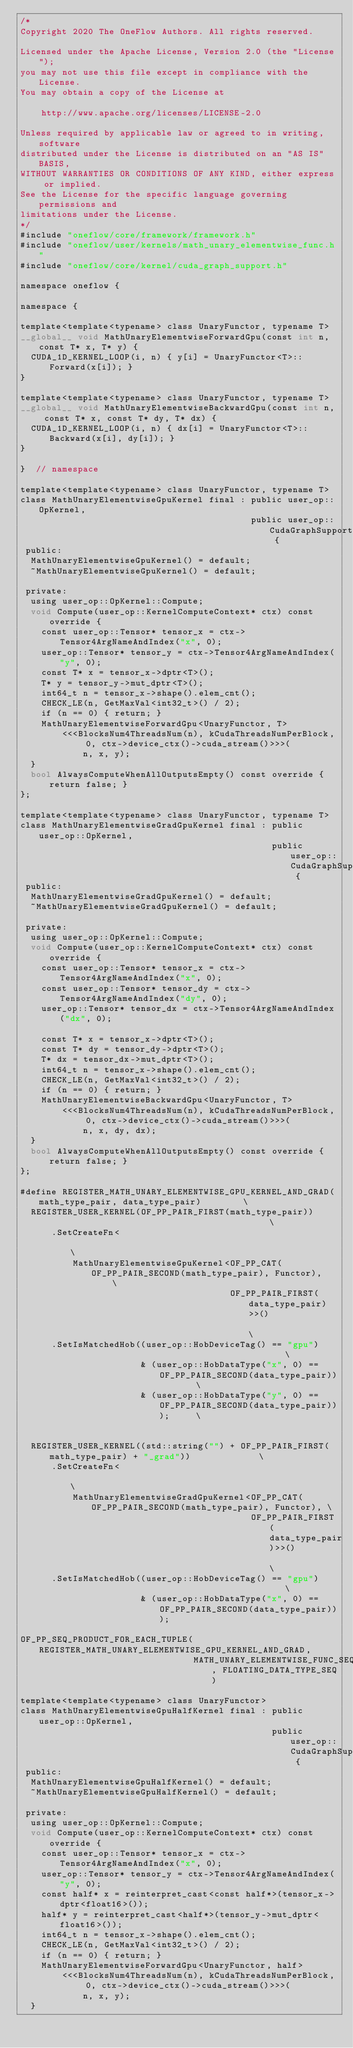Convert code to text. <code><loc_0><loc_0><loc_500><loc_500><_Cuda_>/*
Copyright 2020 The OneFlow Authors. All rights reserved.

Licensed under the Apache License, Version 2.0 (the "License");
you may not use this file except in compliance with the License.
You may obtain a copy of the License at

    http://www.apache.org/licenses/LICENSE-2.0

Unless required by applicable law or agreed to in writing, software
distributed under the License is distributed on an "AS IS" BASIS,
WITHOUT WARRANTIES OR CONDITIONS OF ANY KIND, either express or implied.
See the License for the specific language governing permissions and
limitations under the License.
*/
#include "oneflow/core/framework/framework.h"
#include "oneflow/user/kernels/math_unary_elementwise_func.h"
#include "oneflow/core/kernel/cuda_graph_support.h"

namespace oneflow {

namespace {

template<template<typename> class UnaryFunctor, typename T>
__global__ void MathUnaryElementwiseForwardGpu(const int n, const T* x, T* y) {
  CUDA_1D_KERNEL_LOOP(i, n) { y[i] = UnaryFunctor<T>::Forward(x[i]); }
}

template<template<typename> class UnaryFunctor, typename T>
__global__ void MathUnaryElementwiseBackwardGpu(const int n, const T* x, const T* dy, T* dx) {
  CUDA_1D_KERNEL_LOOP(i, n) { dx[i] = UnaryFunctor<T>::Backward(x[i], dy[i]); }
}

}  // namespace

template<template<typename> class UnaryFunctor, typename T>
class MathUnaryElementwiseGpuKernel final : public user_op::OpKernel,
                                            public user_op::CudaGraphSupport {
 public:
  MathUnaryElementwiseGpuKernel() = default;
  ~MathUnaryElementwiseGpuKernel() = default;

 private:
  using user_op::OpKernel::Compute;
  void Compute(user_op::KernelComputeContext* ctx) const override {
    const user_op::Tensor* tensor_x = ctx->Tensor4ArgNameAndIndex("x", 0);
    user_op::Tensor* tensor_y = ctx->Tensor4ArgNameAndIndex("y", 0);
    const T* x = tensor_x->dptr<T>();
    T* y = tensor_y->mut_dptr<T>();
    int64_t n = tensor_x->shape().elem_cnt();
    CHECK_LE(n, GetMaxVal<int32_t>() / 2);
    if (n == 0) { return; }
    MathUnaryElementwiseForwardGpu<UnaryFunctor, T>
        <<<BlocksNum4ThreadsNum(n), kCudaThreadsNumPerBlock, 0, ctx->device_ctx()->cuda_stream()>>>(
            n, x, y);
  }
  bool AlwaysComputeWhenAllOutputsEmpty() const override { return false; }
};

template<template<typename> class UnaryFunctor, typename T>
class MathUnaryElementwiseGradGpuKernel final : public user_op::OpKernel,
                                                public user_op::CudaGraphSupport {
 public:
  MathUnaryElementwiseGradGpuKernel() = default;
  ~MathUnaryElementwiseGradGpuKernel() = default;

 private:
  using user_op::OpKernel::Compute;
  void Compute(user_op::KernelComputeContext* ctx) const override {
    const user_op::Tensor* tensor_x = ctx->Tensor4ArgNameAndIndex("x", 0);
    const user_op::Tensor* tensor_dy = ctx->Tensor4ArgNameAndIndex("dy", 0);
    user_op::Tensor* tensor_dx = ctx->Tensor4ArgNameAndIndex("dx", 0);

    const T* x = tensor_x->dptr<T>();
    const T* dy = tensor_dy->dptr<T>();
    T* dx = tensor_dx->mut_dptr<T>();
    int64_t n = tensor_x->shape().elem_cnt();
    CHECK_LE(n, GetMaxVal<int32_t>() / 2);
    if (n == 0) { return; }
    MathUnaryElementwiseBackwardGpu<UnaryFunctor, T>
        <<<BlocksNum4ThreadsNum(n), kCudaThreadsNumPerBlock, 0, ctx->device_ctx()->cuda_stream()>>>(
            n, x, dy, dx);
  }
  bool AlwaysComputeWhenAllOutputsEmpty() const override { return false; }
};

#define REGISTER_MATH_UNARY_ELEMENTWISE_GPU_KERNEL_AND_GRAD(math_type_pair, data_type_pair)        \
  REGISTER_USER_KERNEL(OF_PP_PAIR_FIRST(math_type_pair))                                           \
      .SetCreateFn<                                                                                \
          MathUnaryElementwiseGpuKernel<OF_PP_CAT(OF_PP_PAIR_SECOND(math_type_pair), Functor),     \
                                        OF_PP_PAIR_FIRST(data_type_pair)>>()                       \
      .SetIsMatchedHob((user_op::HobDeviceTag() == "gpu")                                          \
                       & (user_op::HobDataType("x", 0) == OF_PP_PAIR_SECOND(data_type_pair))       \
                       & (user_op::HobDataType("y", 0) == OF_PP_PAIR_SECOND(data_type_pair)));     \
                                                                                                   \
  REGISTER_USER_KERNEL((std::string("") + OF_PP_PAIR_FIRST(math_type_pair) + "_grad"))             \
      .SetCreateFn<                                                                                \
          MathUnaryElementwiseGradGpuKernel<OF_PP_CAT(OF_PP_PAIR_SECOND(math_type_pair), Functor), \
                                            OF_PP_PAIR_FIRST(data_type_pair)>>()                   \
      .SetIsMatchedHob((user_op::HobDeviceTag() == "gpu")                                          \
                       & (user_op::HobDataType("x", 0) == OF_PP_PAIR_SECOND(data_type_pair)));

OF_PP_SEQ_PRODUCT_FOR_EACH_TUPLE(REGISTER_MATH_UNARY_ELEMENTWISE_GPU_KERNEL_AND_GRAD,
                                 MATH_UNARY_ELEMENTWISE_FUNC_SEQ, FLOATING_DATA_TYPE_SEQ)

template<template<typename> class UnaryFunctor>
class MathUnaryElementwiseGpuHalfKernel final : public user_op::OpKernel,
                                                public user_op::CudaGraphSupport {
 public:
  MathUnaryElementwiseGpuHalfKernel() = default;
  ~MathUnaryElementwiseGpuHalfKernel() = default;

 private:
  using user_op::OpKernel::Compute;
  void Compute(user_op::KernelComputeContext* ctx) const override {
    const user_op::Tensor* tensor_x = ctx->Tensor4ArgNameAndIndex("x", 0);
    user_op::Tensor* tensor_y = ctx->Tensor4ArgNameAndIndex("y", 0);
    const half* x = reinterpret_cast<const half*>(tensor_x->dptr<float16>());
    half* y = reinterpret_cast<half*>(tensor_y->mut_dptr<float16>());
    int64_t n = tensor_x->shape().elem_cnt();
    CHECK_LE(n, GetMaxVal<int32_t>() / 2);
    if (n == 0) { return; }
    MathUnaryElementwiseForwardGpu<UnaryFunctor, half>
        <<<BlocksNum4ThreadsNum(n), kCudaThreadsNumPerBlock, 0, ctx->device_ctx()->cuda_stream()>>>(
            n, x, y);
  }</code> 